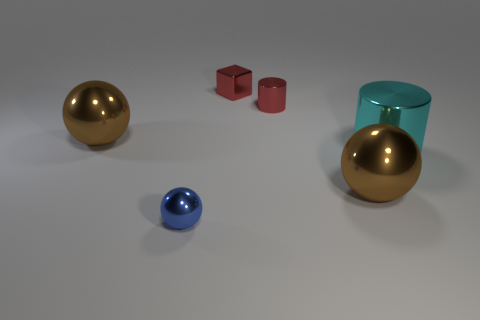Subtract all tiny blue spheres. How many spheres are left? 2 Add 3 small blue metallic balls. How many objects exist? 9 Subtract all brown spheres. How many spheres are left? 1 Subtract all cubes. How many objects are left? 5 Subtract all red cubes. How many brown balls are left? 2 Subtract all red spheres. Subtract all yellow cubes. How many spheres are left? 3 Subtract all large blue metallic blocks. Subtract all large metallic objects. How many objects are left? 3 Add 6 small red shiny objects. How many small red shiny objects are left? 8 Add 1 tiny red blocks. How many tiny red blocks exist? 2 Subtract 0 brown cylinders. How many objects are left? 6 